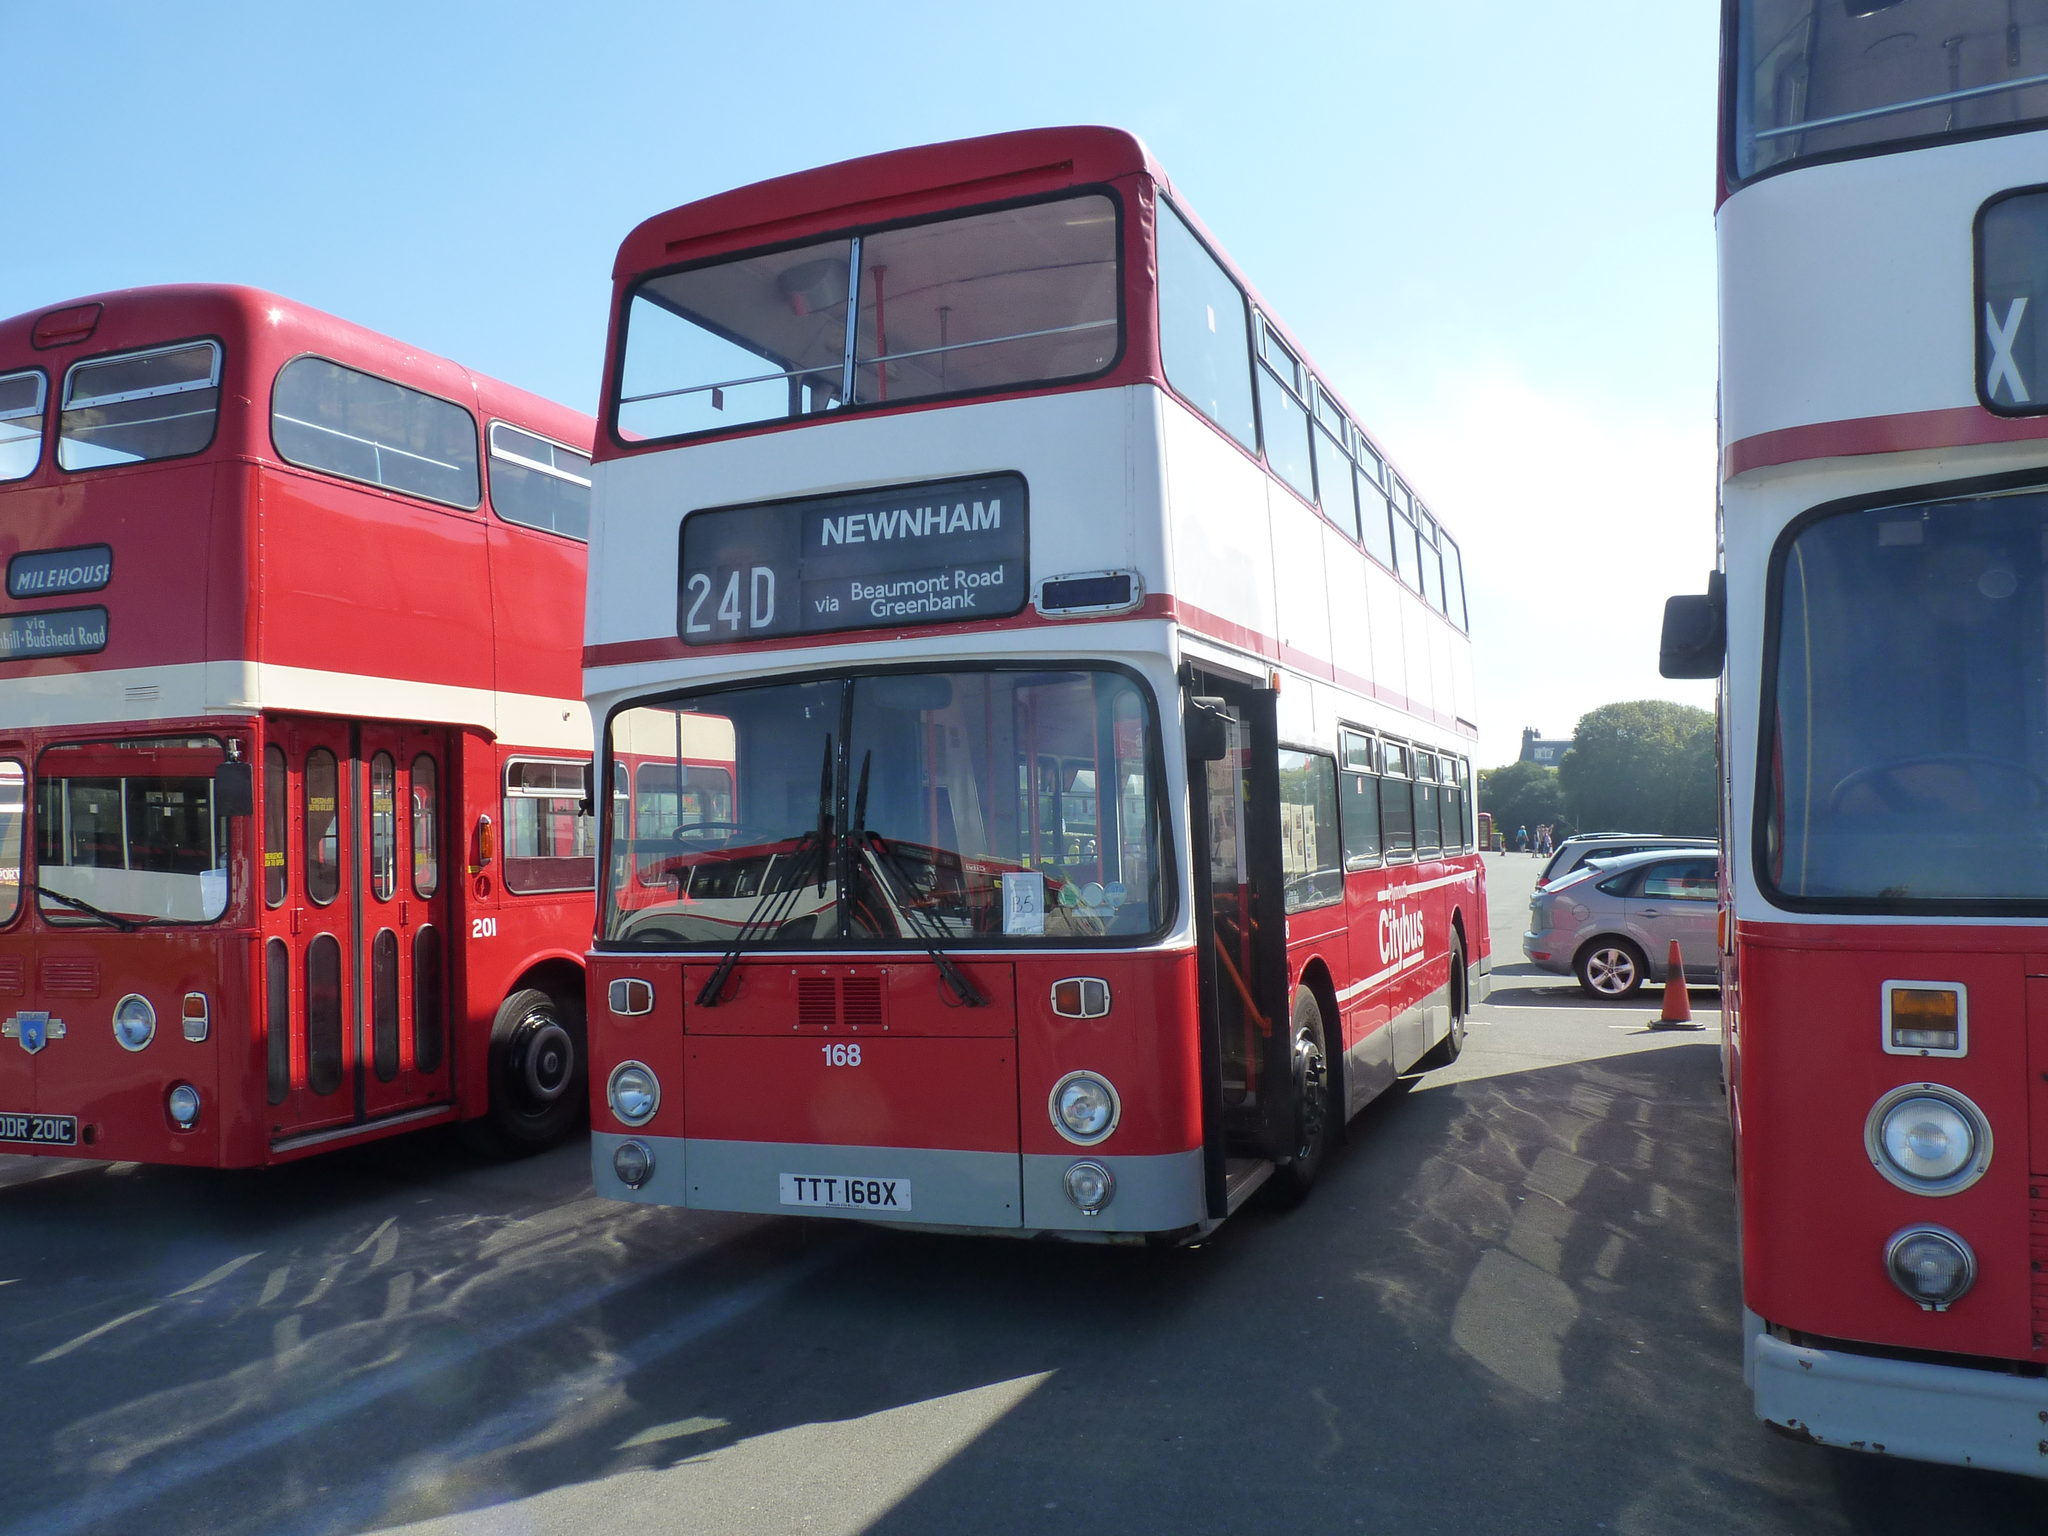Please provide a concise description of this image. In this picture we can see buses, traffic cone, cars on the road and in the background we can see trees, some objects and the sky. 